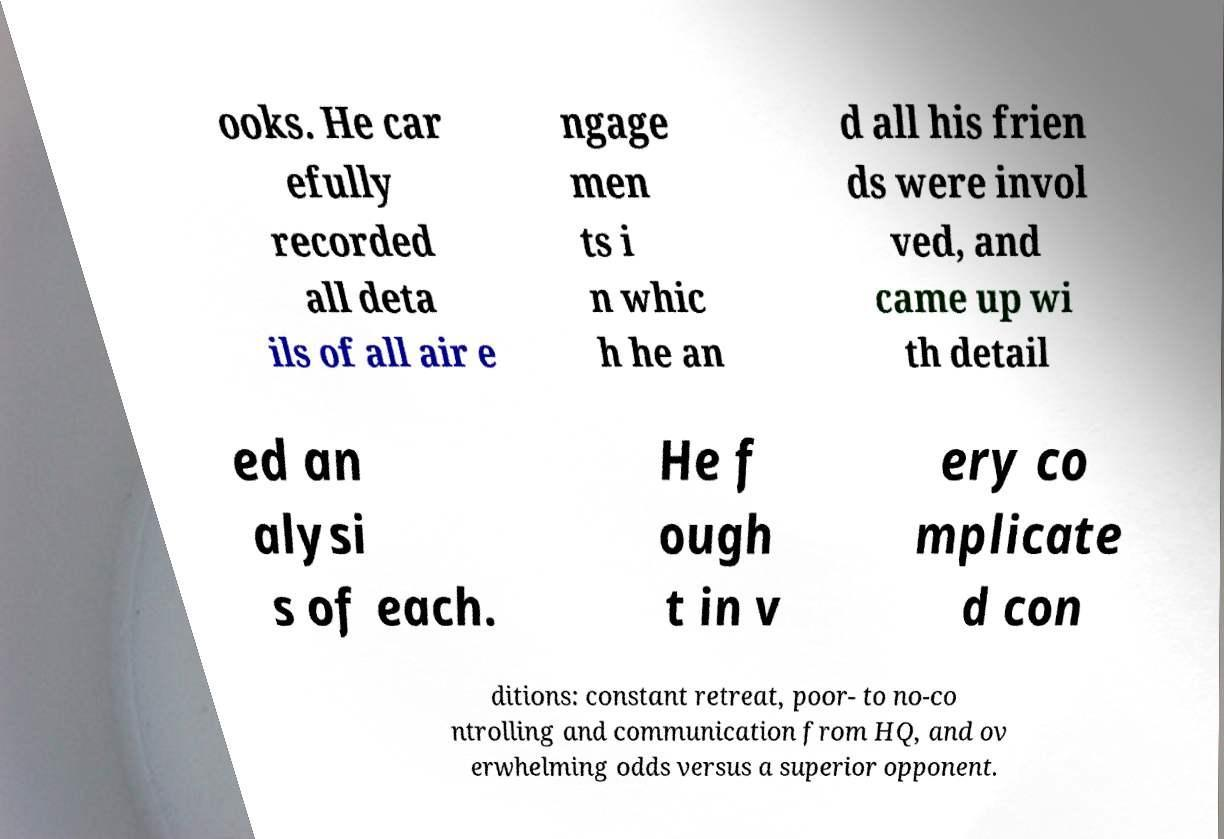Could you extract and type out the text from this image? ooks. He car efully recorded all deta ils of all air e ngage men ts i n whic h he an d all his frien ds were invol ved, and came up wi th detail ed an alysi s of each. He f ough t in v ery co mplicate d con ditions: constant retreat, poor- to no-co ntrolling and communication from HQ, and ov erwhelming odds versus a superior opponent. 